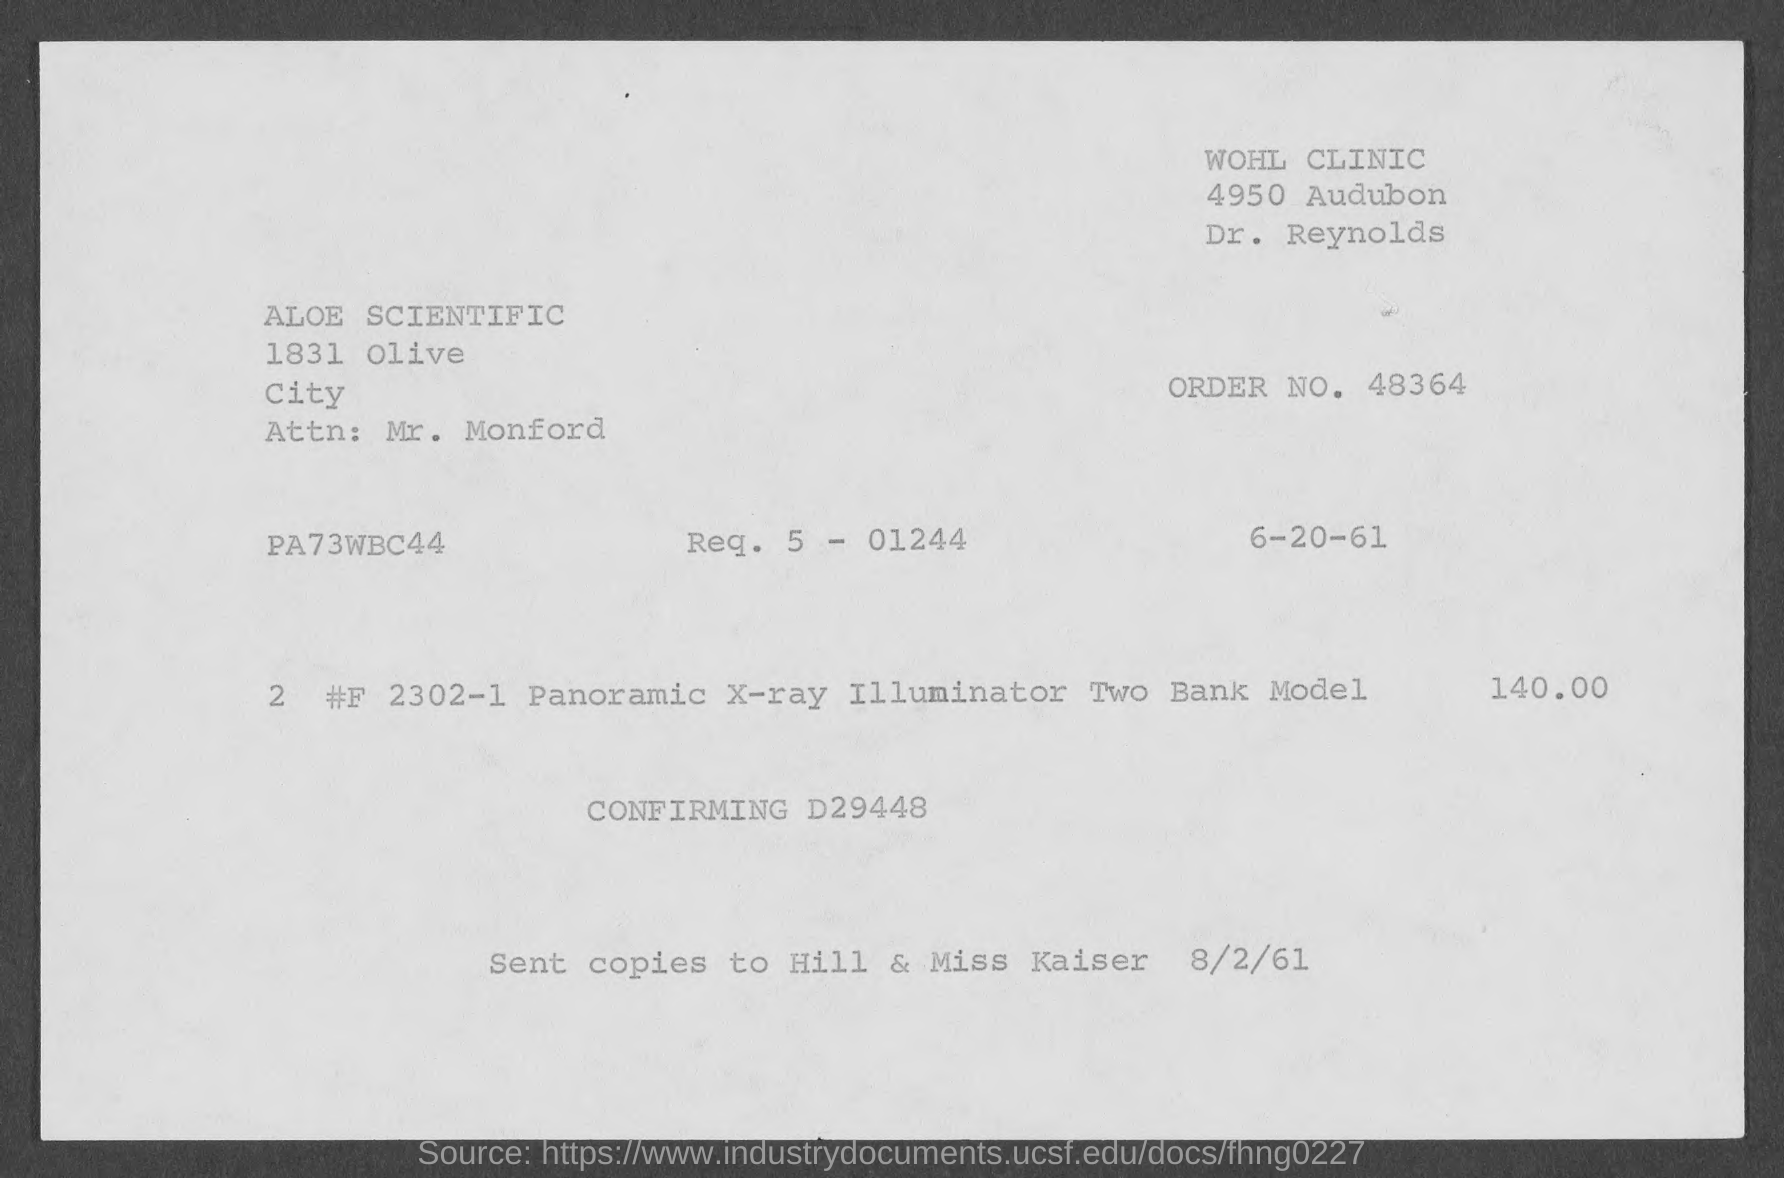What is the order no. mentioned in the given page ?
Offer a very short reply. 48364. What is the name of the city mentioned in the given page ?
Provide a short and direct response. Olive city. What is the date mentioned in the given page ?
Provide a short and direct response. 6-20-61. What is the amount mentioned in the given form ?
Your answer should be compact. 140.00. 